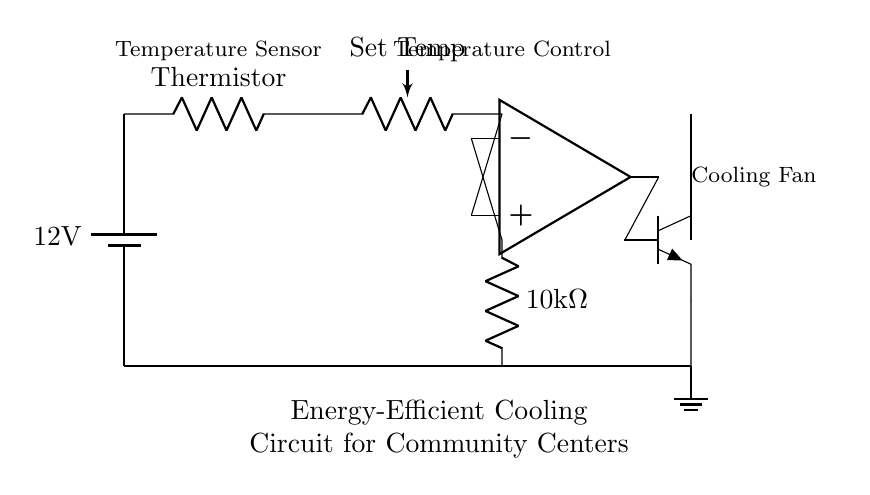What is the voltage supply in this circuit? The voltage supply is indicated by the battery symbol, which shows a potential difference of twelve volts across its terminals.
Answer: twelve volts What component regulates the temperature in the circuit? The temperature regulation is performed by the thermistor, which changes its resistance based on temperature. It is directly connected to the power supply and the op-amp.
Answer: thermistor How many components are connected in series in the circuit? The components in series include the thermistor and the potentiometer as they are connected end-to-end along the same pathway from the power supply.
Answer: two What role does the op-amp serve in this circuit? The op-amp functions as a comparator by comparing the voltage from the thermistor to the reference voltage set by the potentiometer, and controlling the transistor's base to turn the fan on or off accordingly.
Answer: comparator What type of transistor is used in this circuit? The type of transistor in this circuit is an NPN transistor, as denoted by the symbol presented in the diagram, which typically serves for amplifying or switching purposes.
Answer: NPN transistor During operation, what happens when the ambient temperature exceeds the set point? When the ambient temperature exceeds the set point set by the potentiometer, the resistance of the thermistor decreases, causing the op-amp to output a higher signal, which turns on the transistor and activates the cooling fan.
Answer: cooling fan activates What is the purpose of the potentiometer in this circuit? The potentiometer serves to set a reference temperature that the circuit will use to determine when the fan should be activated or deactivated, adjusting the threshold of the op-amp.
Answer: set temperature 